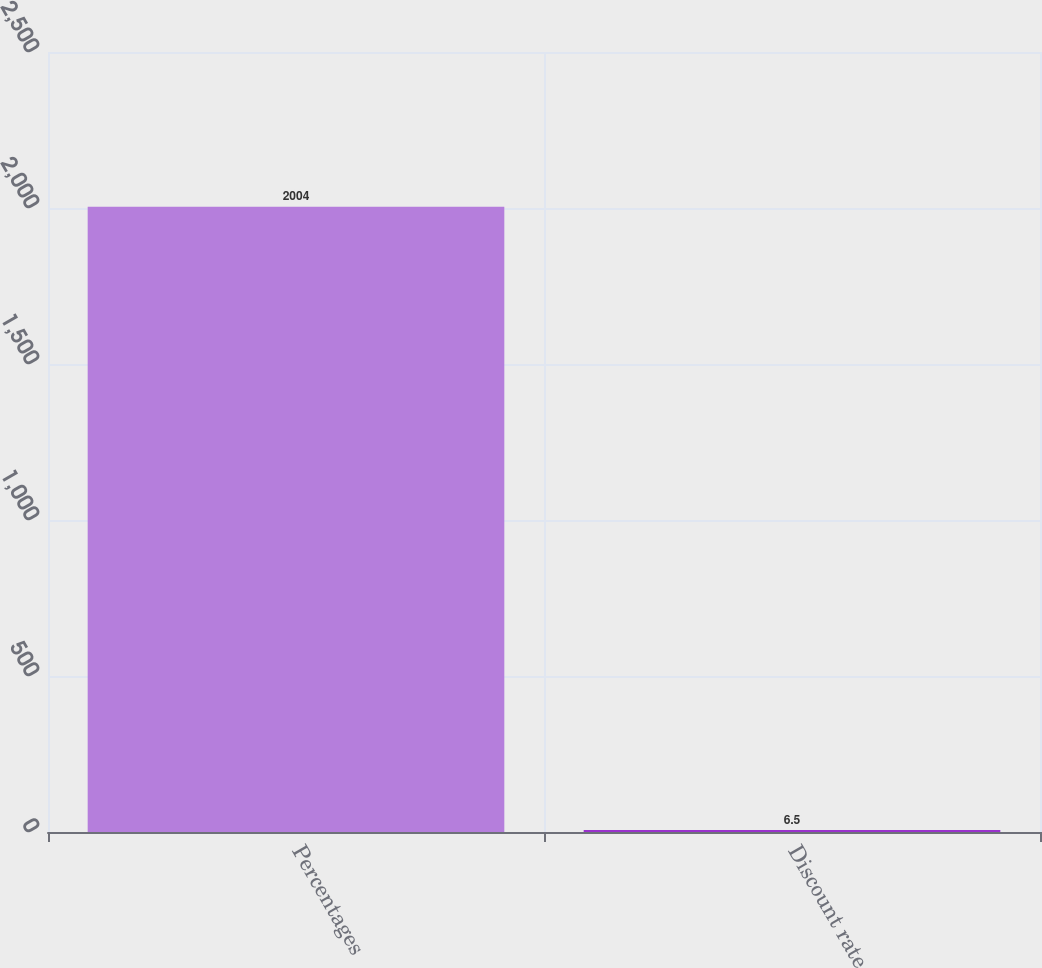<chart> <loc_0><loc_0><loc_500><loc_500><bar_chart><fcel>Percentages<fcel>Discount rate<nl><fcel>2004<fcel>6.5<nl></chart> 